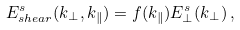<formula> <loc_0><loc_0><loc_500><loc_500>E _ { s h e a r } ^ { s } ( k _ { \perp } , k _ { \| } ) = f ( k _ { \| } ) E ^ { s } _ { \perp } ( k _ { \perp } ) \, ,</formula> 